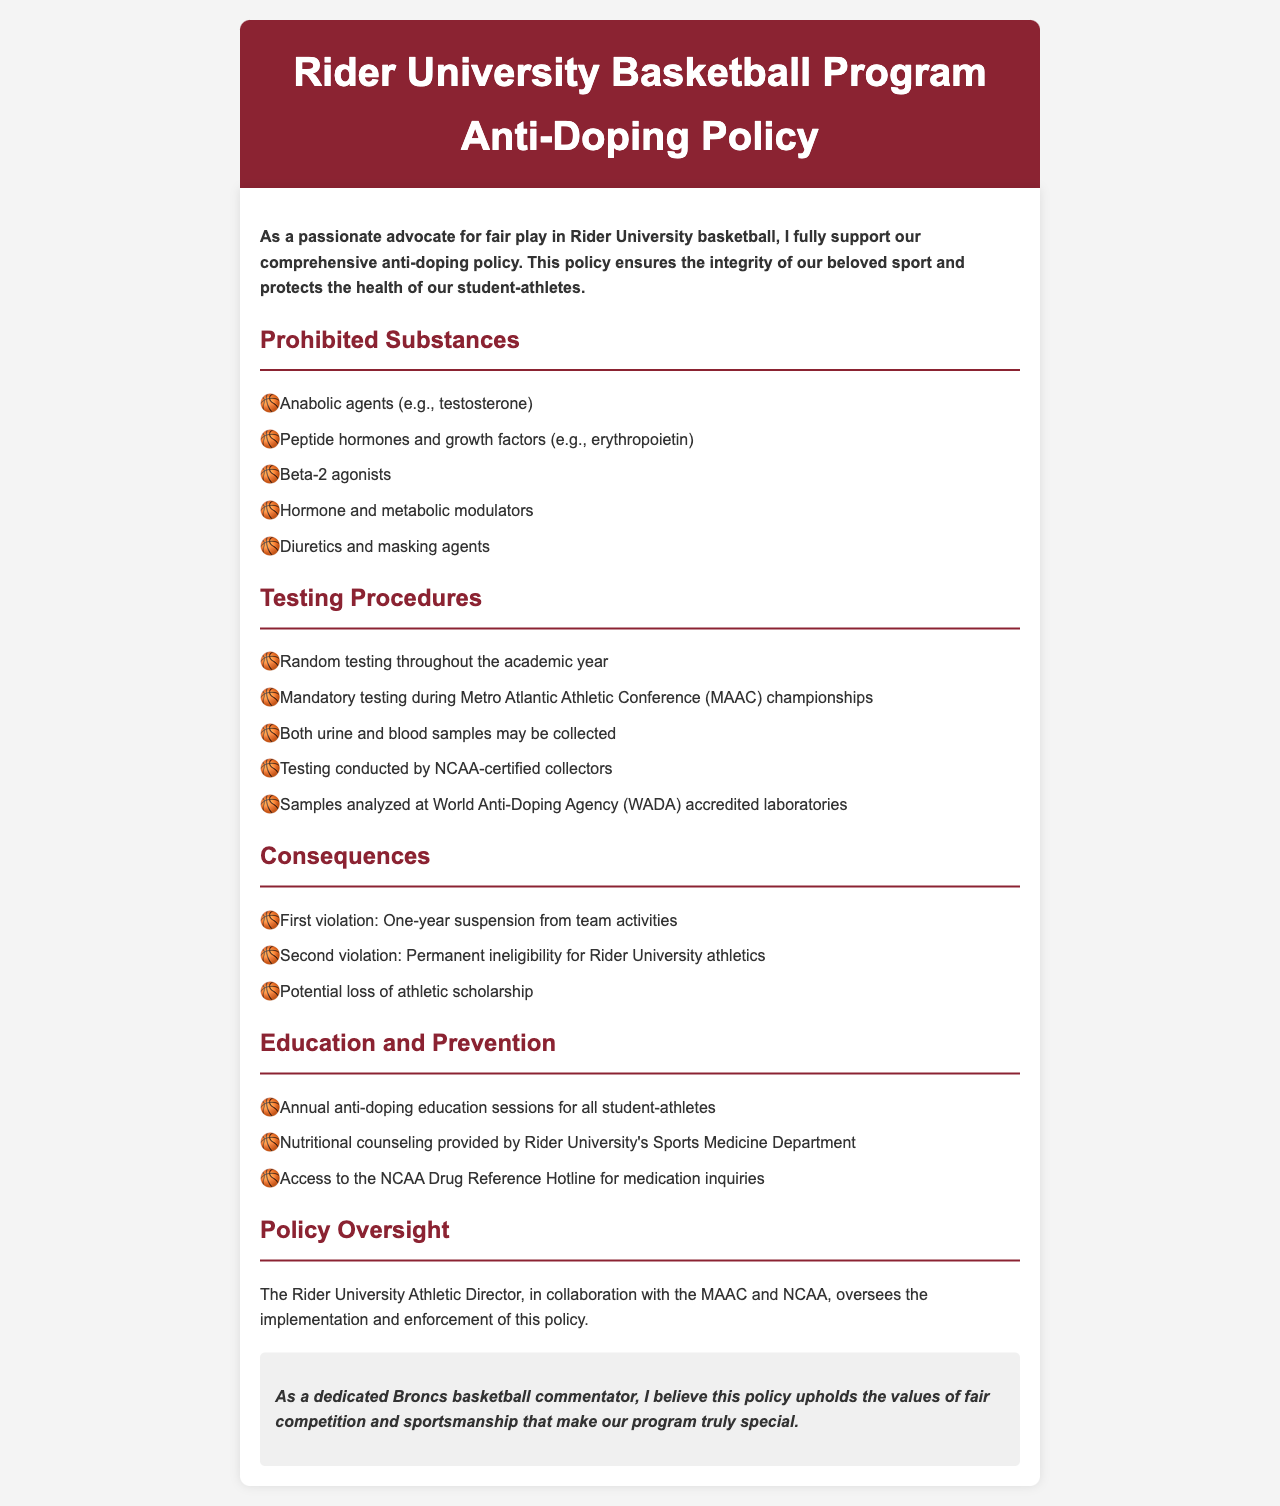What are anabolic agents? Anabolic agents are a category of prohibited substances listed under the policy; one example mentioned is testosterone.
Answer: anabolic agents (e.g., testosterone) What type of samples may be collected during testing? The policy states that both urine and blood samples may be collected for testing purposes.
Answer: urine and blood samples What happens after a second violation of the anti-doping policy? According to the policy, a second violation leads to permanent ineligibility for Rider University athletics.
Answer: Permanent ineligibility for Rider University athletics Who oversees the implementation of the anti-doping policy? The document mentions that the Rider University Athletic Director, in collaboration with the MAAC and NCAA, oversees the policy's implementation.
Answer: Rider University Athletic Director How often is random testing conducted? The policy indicates that random testing is conducted throughout the academic year.
Answer: throughout the academic year What is one of the consequences for a first violation? For a first violation of the anti-doping policy, the consequence is a one-year suspension from team activities.
Answer: One-year suspension from team activities What is provided to student-athletes for nutritional counseling? The document states that nutritional counseling is provided by Rider University's Sports Medicine Department.
Answer: Rider University's Sports Medicine Department Where are the samples analyzed? Samples are analyzed at World Anti-Doping Agency (WADA) accredited laboratories as stated in the policy.
Answer: World Anti-Doping Agency (WADA) accredited laboratories 